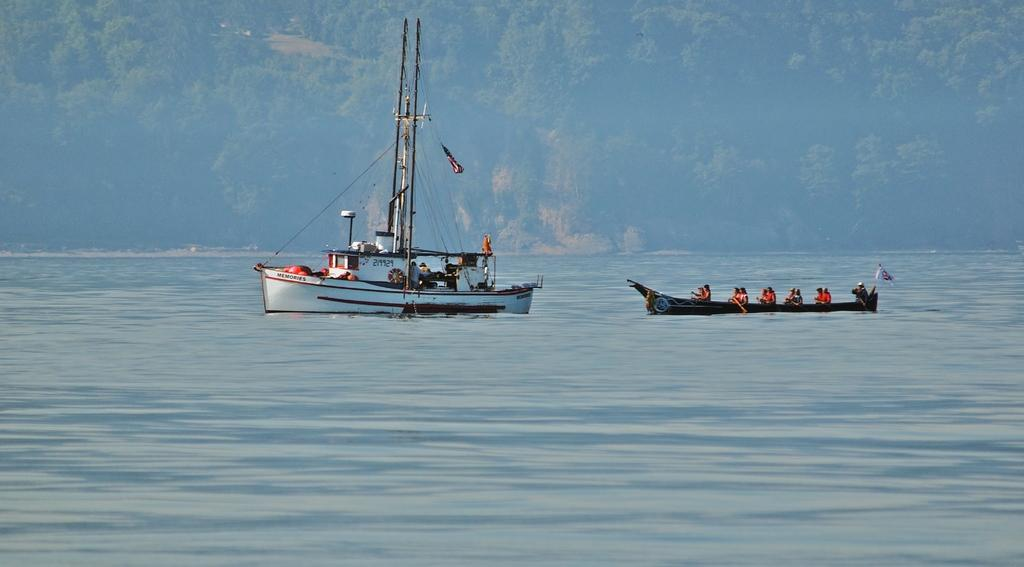What type of ship is in the image? There is a trireme in the image. What is the trireme doing in the image? The trireme is sailing on water. What are the people in the boat doing in the image? The people in the boat are rowing. What can be seen in the background of the image? There are trees and a mountain in the background of the image. Can you see an airplane flying over the mountain in the image? There is no airplane visible in the image; it only features a trireme sailing on water, people rowing in a boat, and a mountain and trees in the background. 